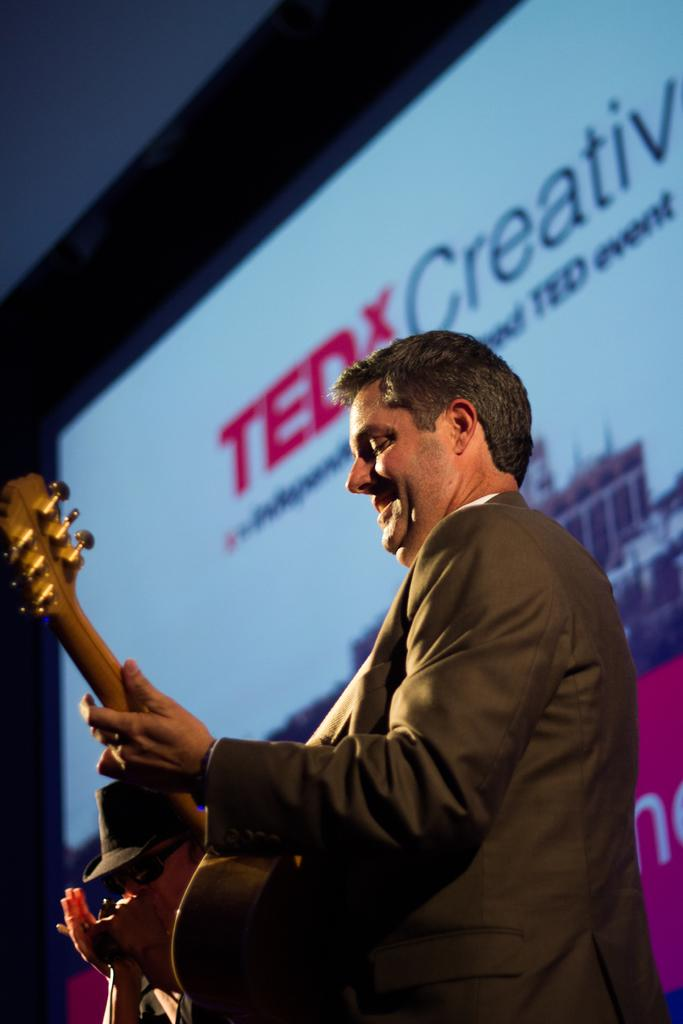What is the main subject of the image? The main subject of the image is a man. What is the man holding in the image? The man is holding a guitar. What type of government is depicted in the image? There is no depiction of a government in the image; it features a man holding a guitar. What arithmetic problem is the man solving in the image? There is no arithmetic problem present in the image; it features a man holding a guitar. 